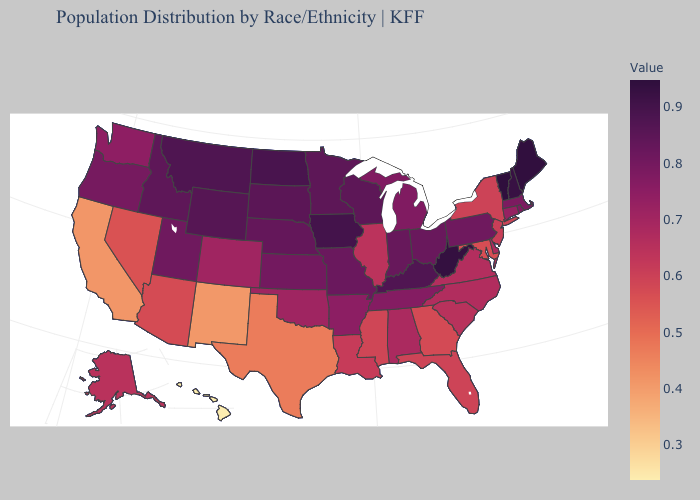Does Washington have the highest value in the West?
Concise answer only. No. Does Tennessee have a lower value than Idaho?
Keep it brief. Yes. Among the states that border Nebraska , does South Dakota have the lowest value?
Short answer required. No. Among the states that border South Carolina , does Georgia have the highest value?
Be succinct. No. Which states have the lowest value in the West?
Be succinct. Hawaii. 